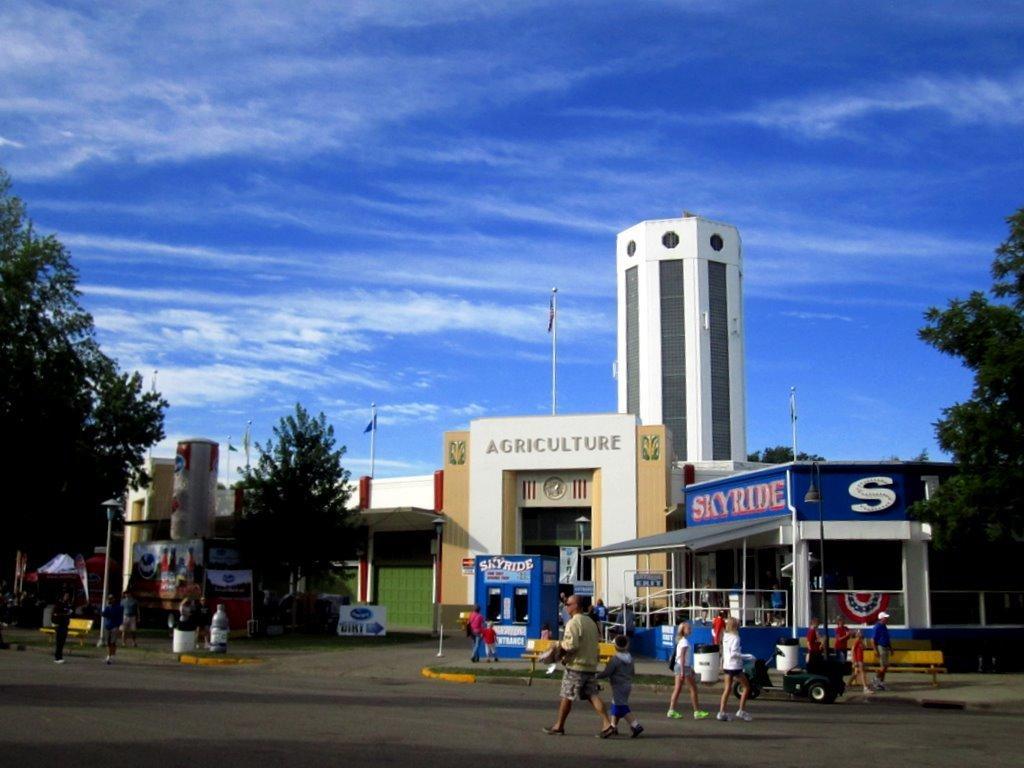Please provide a concise description of this image. In the foreground of this image, there are persons walking on the road. In the background, there are trees, buildings, flags, a vehicle on the road, few dustbins, sky and the cloud. 